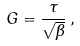Convert formula to latex. <formula><loc_0><loc_0><loc_500><loc_500>G = \frac { \tau } { \sqrt { \beta } } \, ,</formula> 